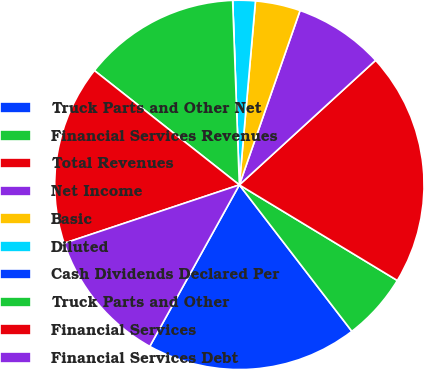Convert chart to OTSL. <chart><loc_0><loc_0><loc_500><loc_500><pie_chart><fcel>Truck Parts and Other Net<fcel>Financial Services Revenues<fcel>Total Revenues<fcel>Net Income<fcel>Basic<fcel>Diluted<fcel>Cash Dividends Declared Per<fcel>Truck Parts and Other<fcel>Financial Services<fcel>Financial Services Debt<nl><fcel>18.49%<fcel>5.91%<fcel>20.45%<fcel>7.88%<fcel>3.94%<fcel>1.97%<fcel>0.0%<fcel>13.79%<fcel>15.75%<fcel>11.82%<nl></chart> 